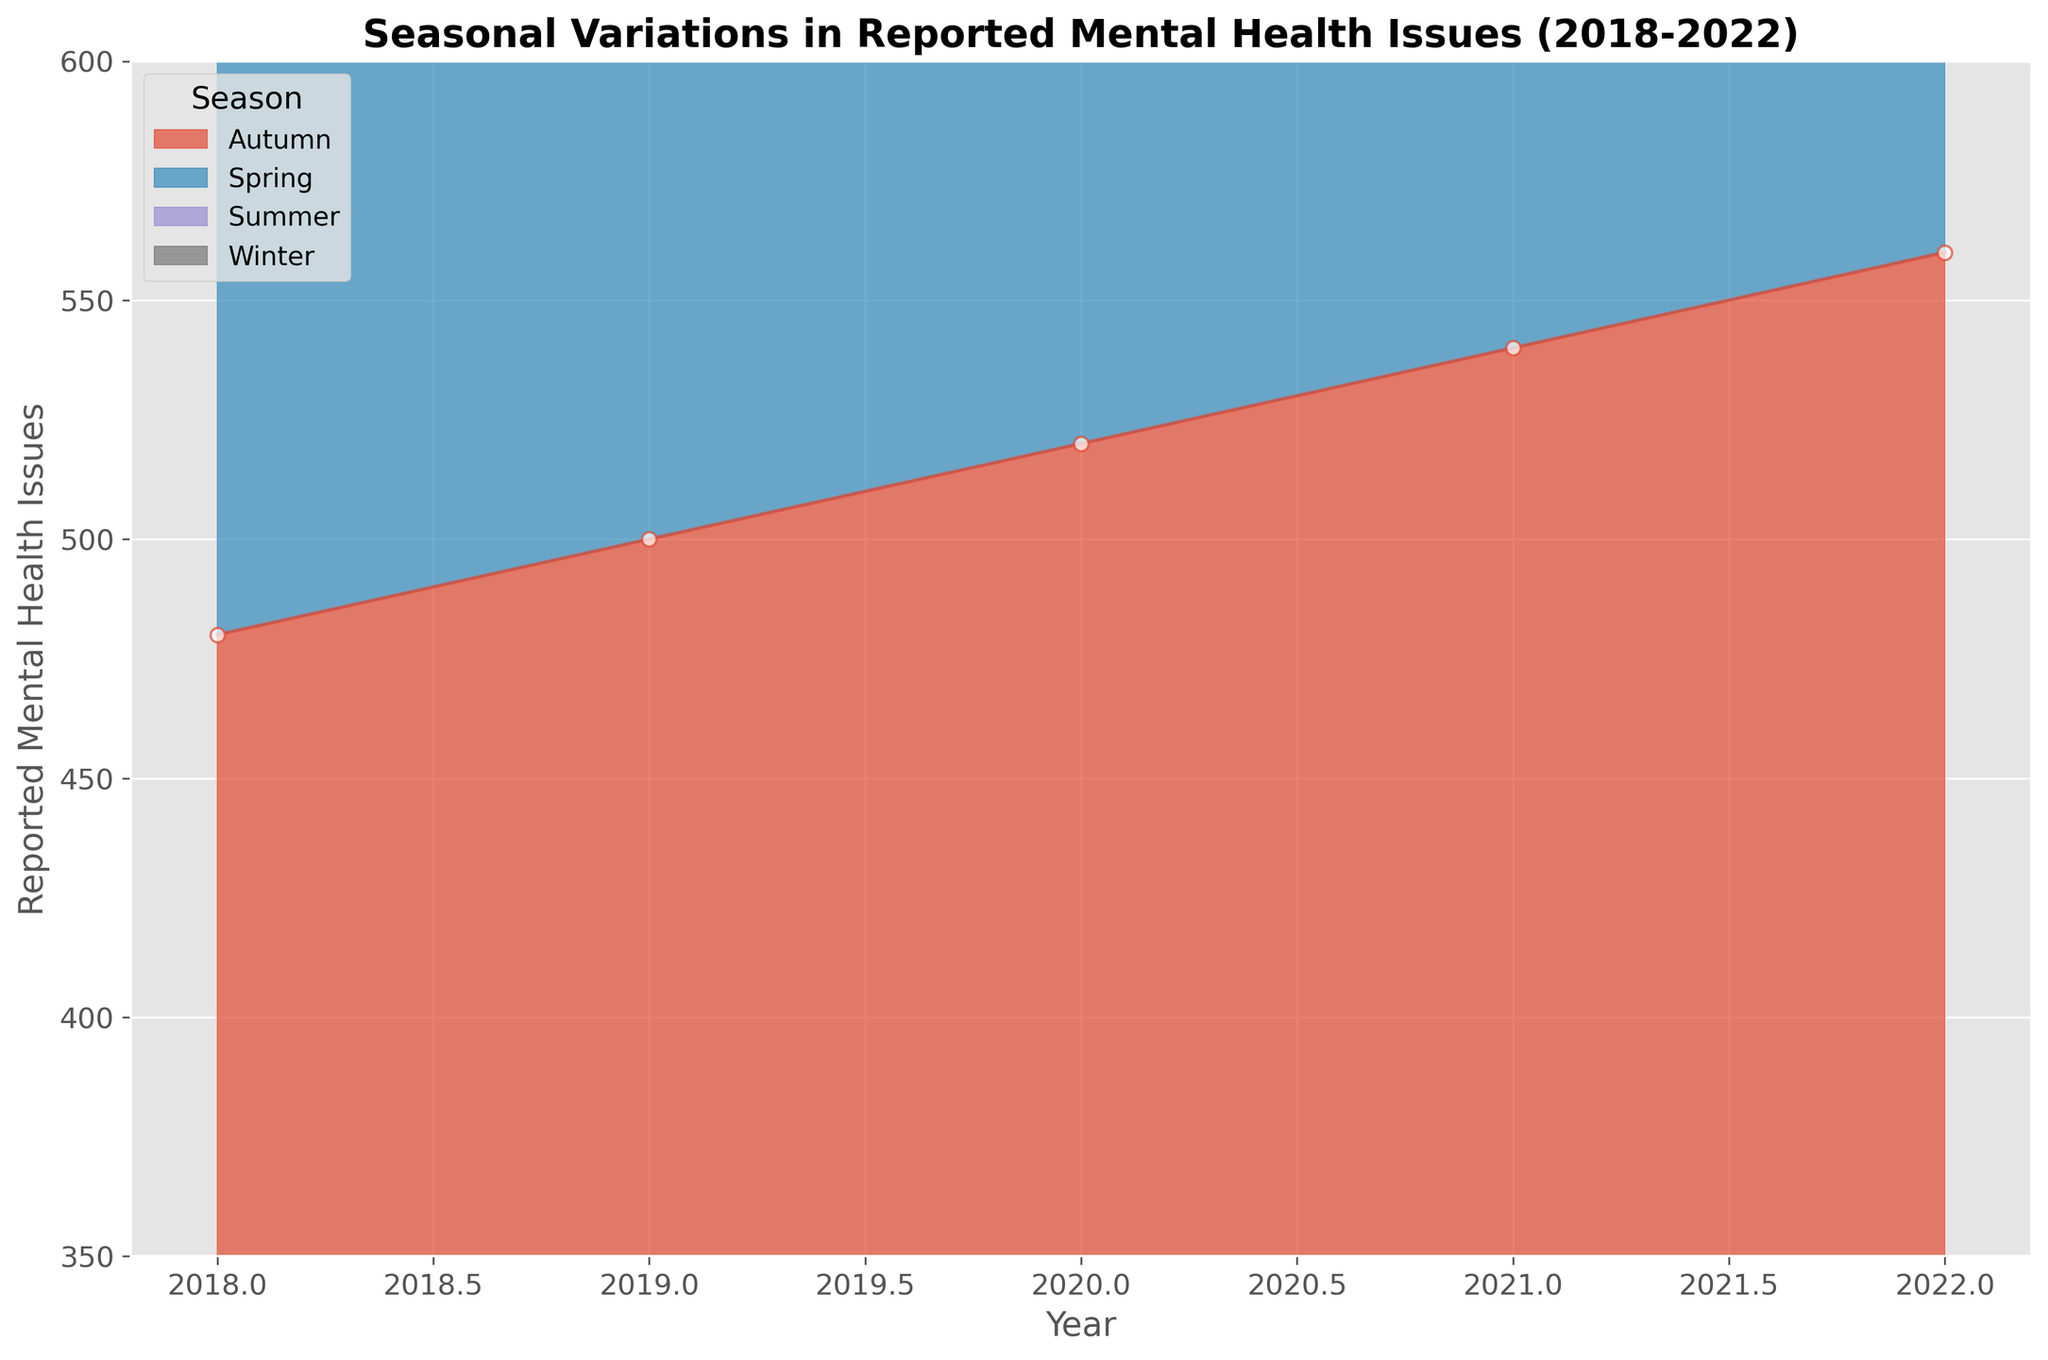What season has the highest reported mental health issues in 2022? To find the highest reported mental health issues in 2022, look at the height of areas representing each season for the year 2022. The tallest one will indicate the season with the highest issues.
Answer: Winter How do the reported mental health issues in Summer 2018 compare with Summer 2022? Identify the Heights of the areas representing Summer in both 2018 and 2022. Compare these heights to determine which one is taller or if they are equal.
Answer: 2022 is higher What is the overall trend in reported mental health issues from Winter 2018 to Winter 2022? Look at the heights of the areas for Winter at the start (2018) and end (2022) of the timeline. Notice if the areas are growing taller over time.
Answer: Increasing Which season shows the smallest change in reported mental health issues from 2018 to 2022? Compare the heights of the areas for each season between 2018 and 2022. The season with the smallest variation in height shows the least change.
Answer: Summer What is the average reported mental health issues over the five-year period for Autumn? Calculate the average of the reported mental health issues for Autumn from 2018 to 2022. Sum the values for Autumn across these years and divide by the number of years (5).
Answer: 520 If we sum up the reported mental health issues for all seasons in 2021, what is the total? Sum the reported mental health issues for all four seasons (Winter, Spring, Summer, Autumn) in 2021. Add these values together.
Answer: 2070 Considering the difference between Winter and Summer in 2020, which one witnessed more reported mental health issues? Compare the heights of the areas representing Winter and Summer in 2020. Determine the taller one to identify which had more issues.
Answer: Winter How does Spring 2019 compare to Spring 2021 in terms of reported mental health issues? Look at the areas representing Spring in both 2019 and 2021. Compare these heights visually to see which is taller.
Answer: 2021 is higher 